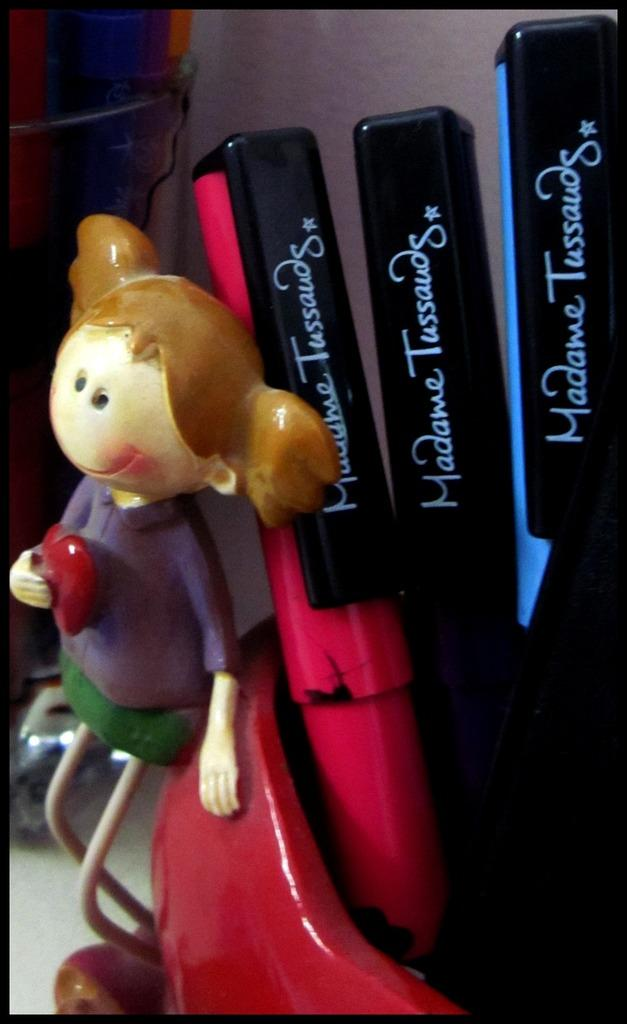<image>
Offer a succinct explanation of the picture presented. Clay girl sits on a cup full of Madame Tussauds markers. 